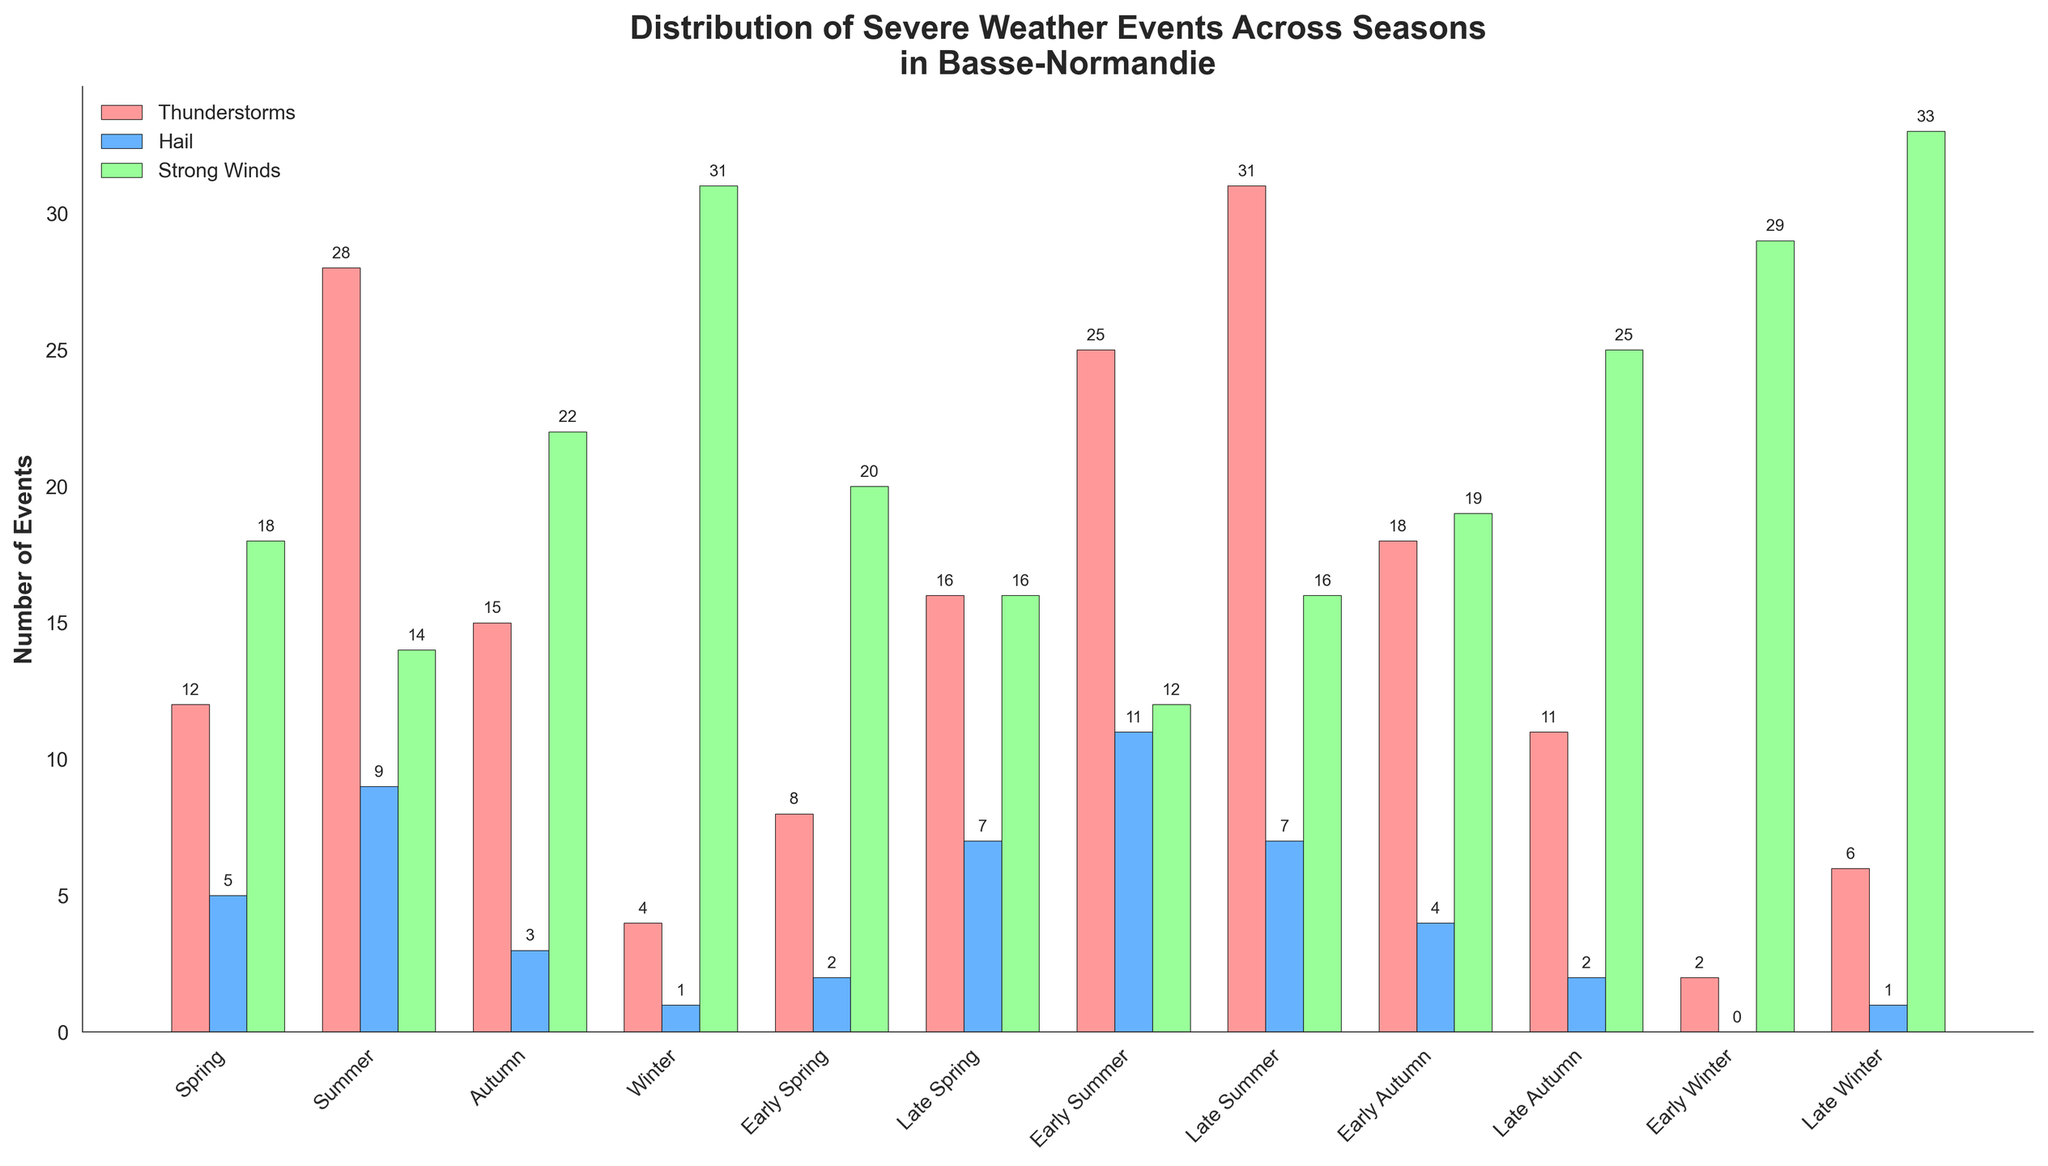Which season has the highest number of thunderstorms? By looking at the heights of the bars representing thunderstorms, the tallest bar is in Late Summer. This indicates that Late Summer has the highest number of thunderstorms.
Answer: Late Summer How many hail events occurred in Spring and Summer combined? To find the total number of hail events for Spring and Summer, add the values for Spring (5) and Summer (9).
Answer: 14 Which season experienced fewer strong winds: Early Autumn or Late Autumn? Compare the height of the bars for strong winds between Early Autumn (19) and Late Autumn (25). Early Autumn has fewer strong winds.
Answer: Early Autumn What is the difference in the number of thunderstorms between Early Summer and Late Summer? Subtract the number of thunderstorms in Early Summer (25) from the number in Late Summer (31).
Answer: 6 How many total weather events (thunderstorms, hail, and strong winds) occurred in Winter? Sum up the values for Winter: 4 (thunderstorms), 1 (hail), and 31 (strong winds).
Answer: 36 Which weather event is least common in Early Winter? By looking at the three bar heights for Early Winter, the smallest bar represents hail (0).
Answer: Hail Is the number of strong winds greater in Early Summer or Late Summer? Compare the heights of the strong winds bars for Early Summer (12) and Late Summer (16). Late Summer has more strong winds.
Answer: Late Summer What is the total number of thunderstorms across all seasons? Add up the numbers of thunderstorms for all seasons: 12 + 28 + 15 + 4 + 8 + 16 + 25 + 31 + 18 + 11 + 2 + 6.
Answer: 176 Which color represents hail in the chart? Observe the legend in the chart to see which color corresponds to hail. The color is light blue.
Answer: Light blue How does the number of hail events in Spring compare to the number of strong winds in Spring? Compare the heights of the bars for hail (5) and strong winds (18) in Spring. Strong winds are more common.
Answer: Strong winds are more common 